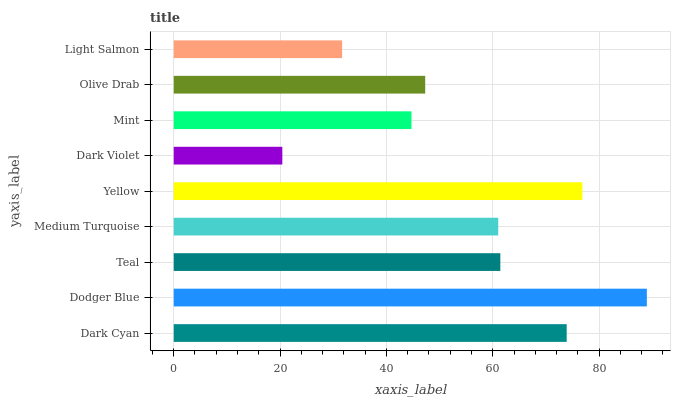Is Dark Violet the minimum?
Answer yes or no. Yes. Is Dodger Blue the maximum?
Answer yes or no. Yes. Is Teal the minimum?
Answer yes or no. No. Is Teal the maximum?
Answer yes or no. No. Is Dodger Blue greater than Teal?
Answer yes or no. Yes. Is Teal less than Dodger Blue?
Answer yes or no. Yes. Is Teal greater than Dodger Blue?
Answer yes or no. No. Is Dodger Blue less than Teal?
Answer yes or no. No. Is Medium Turquoise the high median?
Answer yes or no. Yes. Is Medium Turquoise the low median?
Answer yes or no. Yes. Is Dodger Blue the high median?
Answer yes or no. No. Is Dodger Blue the low median?
Answer yes or no. No. 